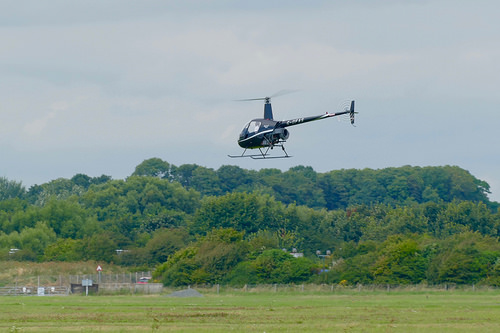<image>
Is the helicopter on the trees? No. The helicopter is not positioned on the trees. They may be near each other, but the helicopter is not supported by or resting on top of the trees. 